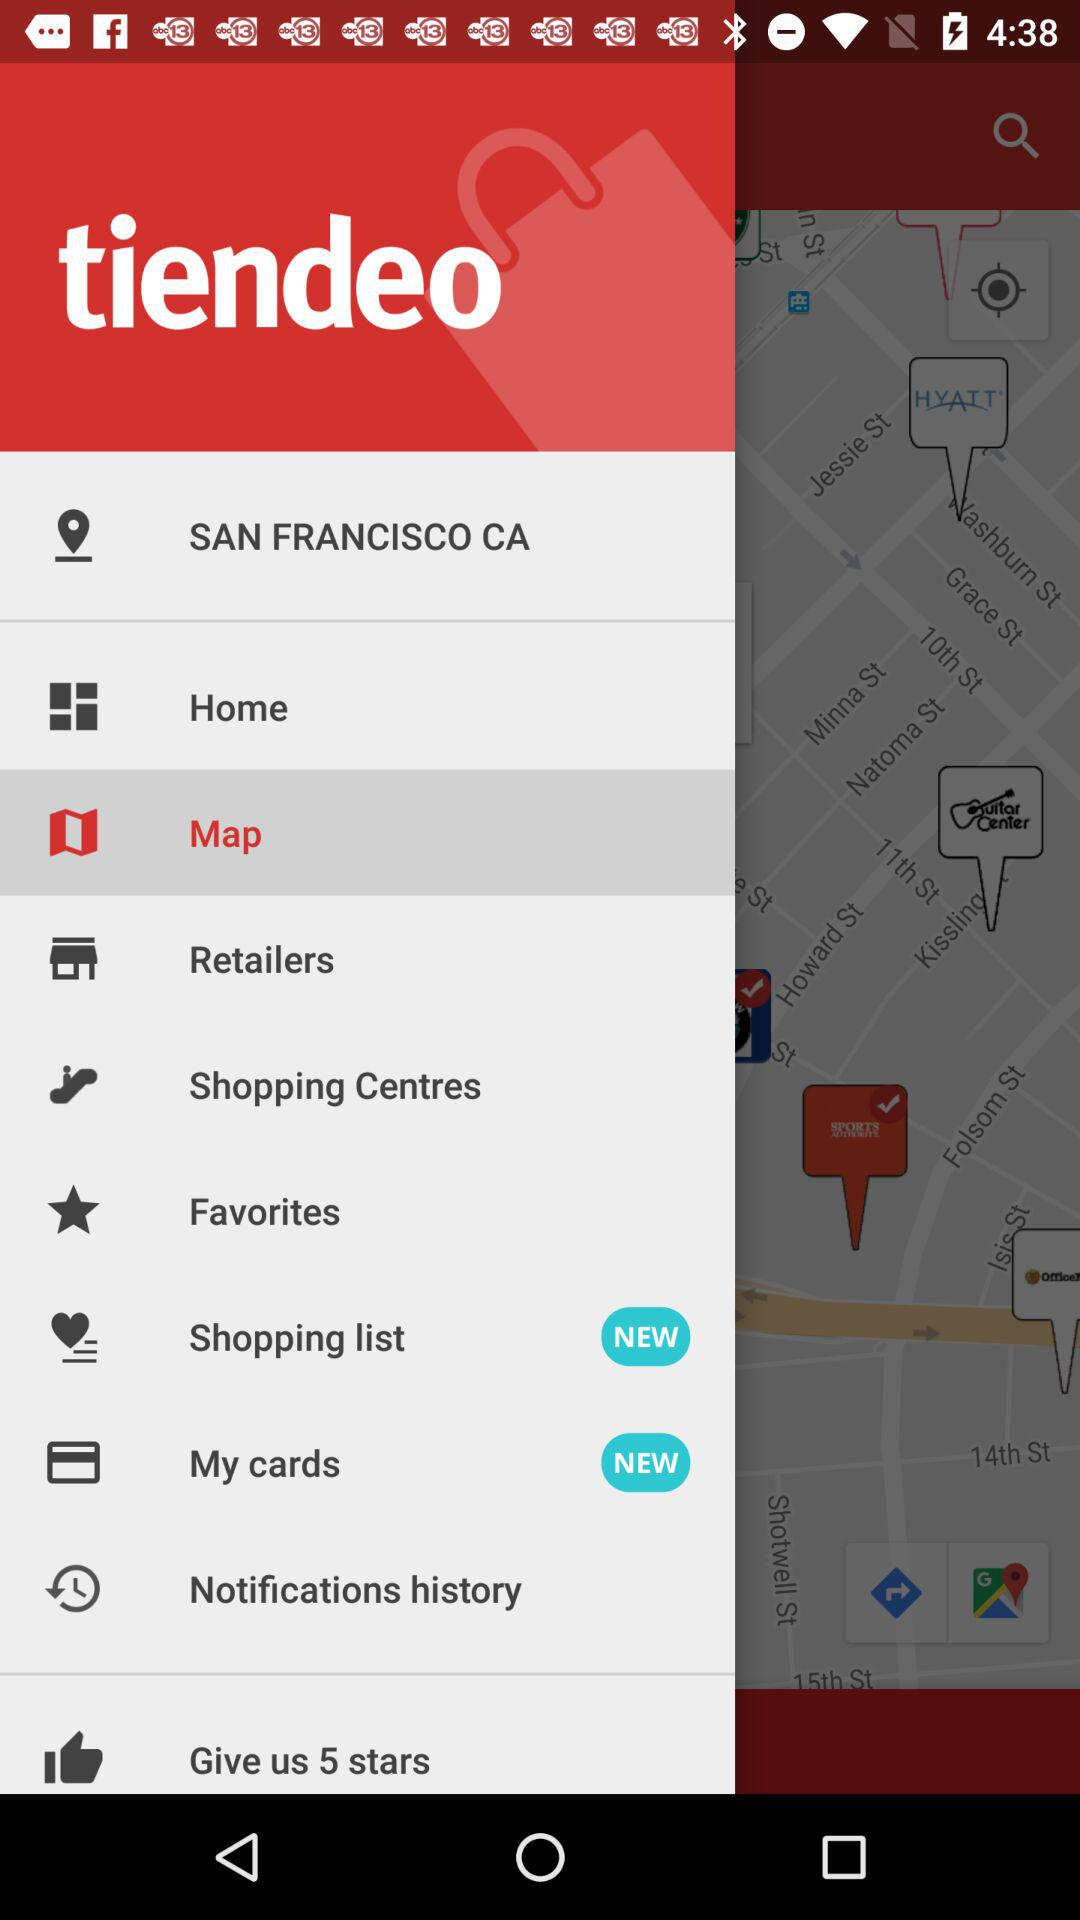Which location is given? The given location is San Francisco, CA. 